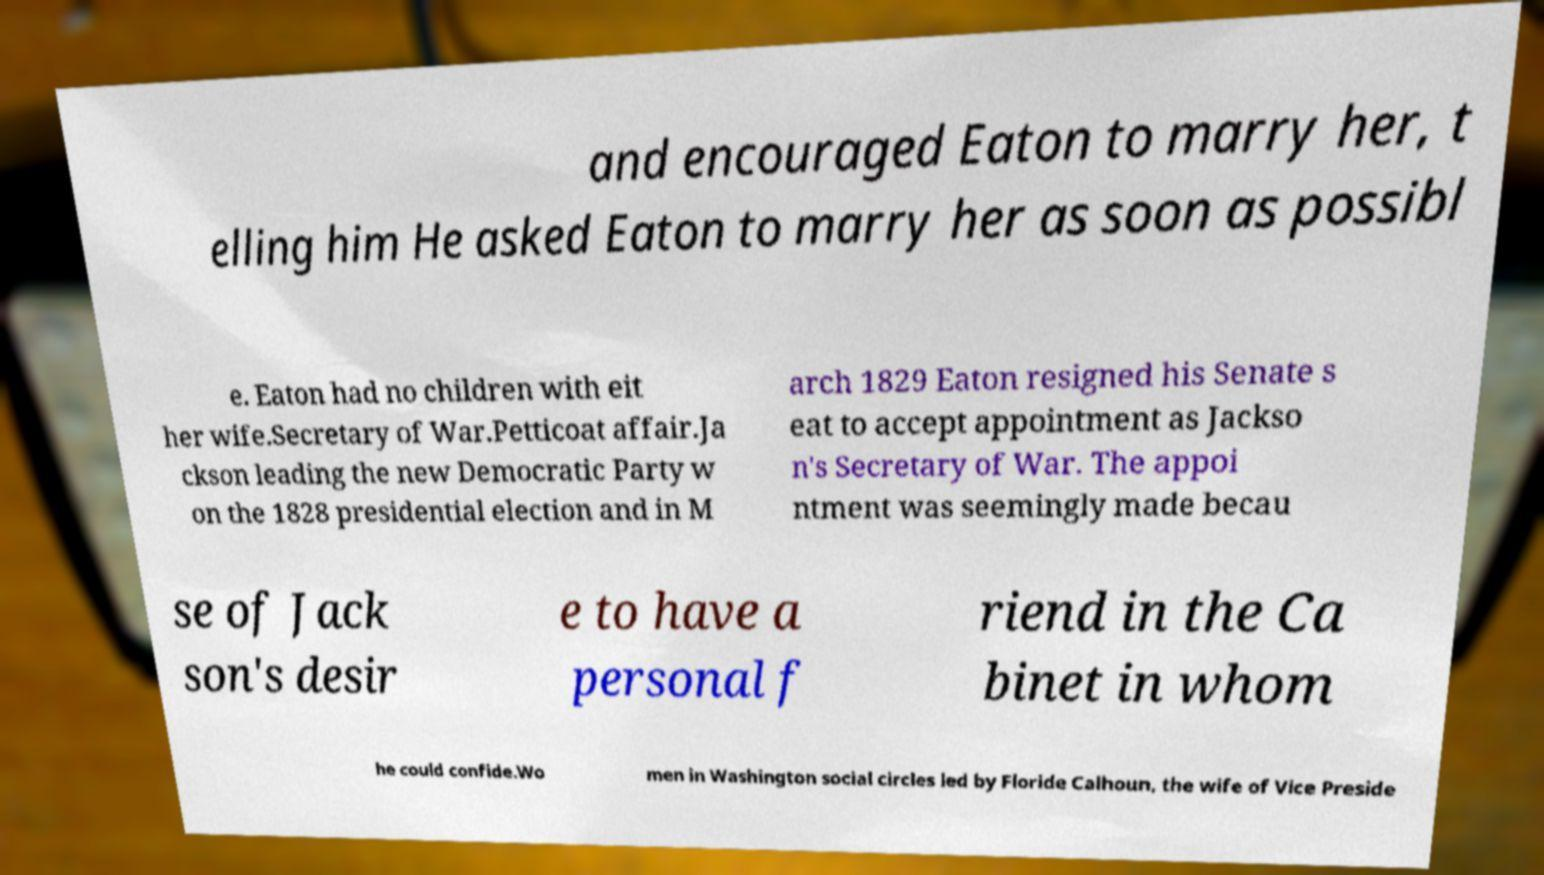Please identify and transcribe the text found in this image. and encouraged Eaton to marry her, t elling him He asked Eaton to marry her as soon as possibl e. Eaton had no children with eit her wife.Secretary of War.Petticoat affair.Ja ckson leading the new Democratic Party w on the 1828 presidential election and in M arch 1829 Eaton resigned his Senate s eat to accept appointment as Jackso n's Secretary of War. The appoi ntment was seemingly made becau se of Jack son's desir e to have a personal f riend in the Ca binet in whom he could confide.Wo men in Washington social circles led by Floride Calhoun, the wife of Vice Preside 